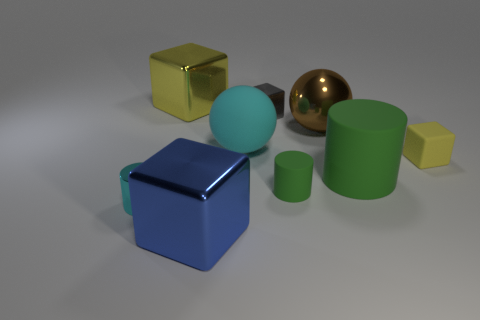What number of tiny yellow cubes are the same material as the small green cylinder?
Make the answer very short. 1. Are there more rubber cylinders than cylinders?
Your answer should be compact. No. There is a small metal object that is behind the small matte cube; what number of big shiny things are in front of it?
Provide a succinct answer. 2. How many things are either tiny objects that are to the left of the blue block or big objects?
Make the answer very short. 6. Are there any other matte things that have the same shape as the big brown thing?
Your response must be concise. Yes. What shape is the large metallic thing in front of the small yellow matte thing that is to the right of the metallic cylinder?
Provide a short and direct response. Cube. How many cubes are either big brown things or blue shiny objects?
Provide a succinct answer. 1. What is the material of the tiny cylinder that is the same color as the big cylinder?
Provide a succinct answer. Rubber. There is a yellow object on the right side of the large blue thing; is its shape the same as the green matte thing on the left side of the large rubber cylinder?
Give a very brief answer. No. What color is the big shiny object that is both behind the large green cylinder and to the left of the small green rubber cylinder?
Ensure brevity in your answer.  Yellow. 